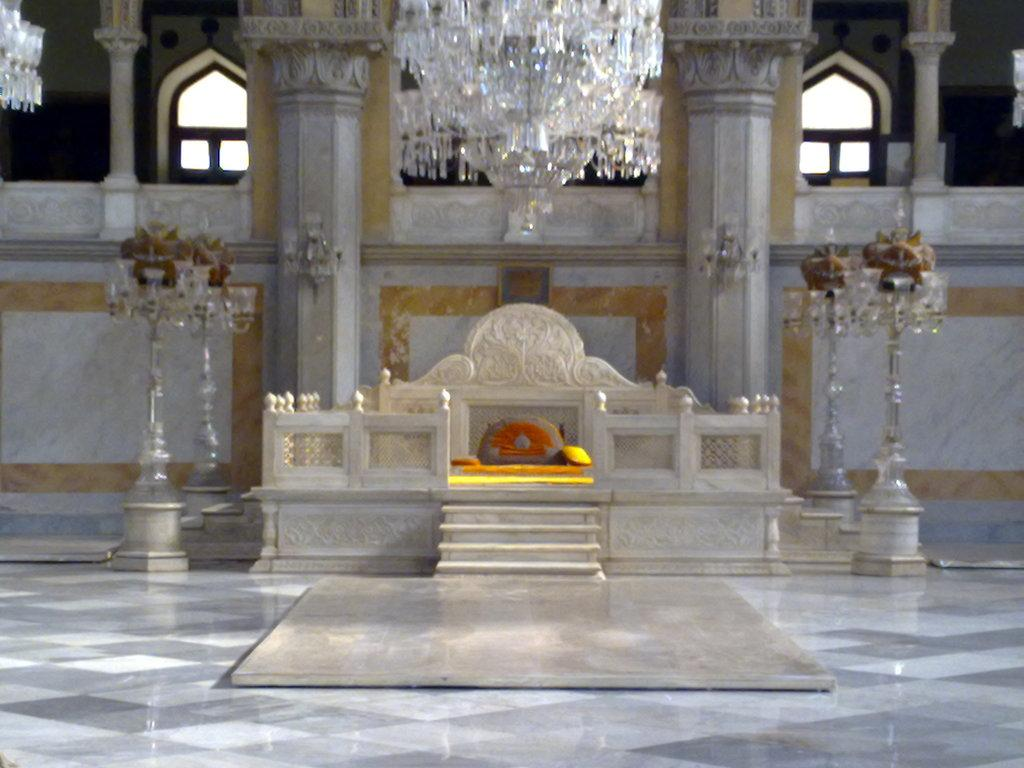What type of seating is present in the image? There is a concrete seat in the image. What is hanging from the ceiling in the image? There is a chandelier at the top of the image. What can be seen in the background of the image? There are windows visible in the background of the image. Can you hear the horn of the vehicle in the image? There is no vehicle or horn present in the image. What type of sorting algorithm is being used by the chandelier in the image? The chandelier is not a computer program or algorithm, so it is not using any sorting algorithm. 